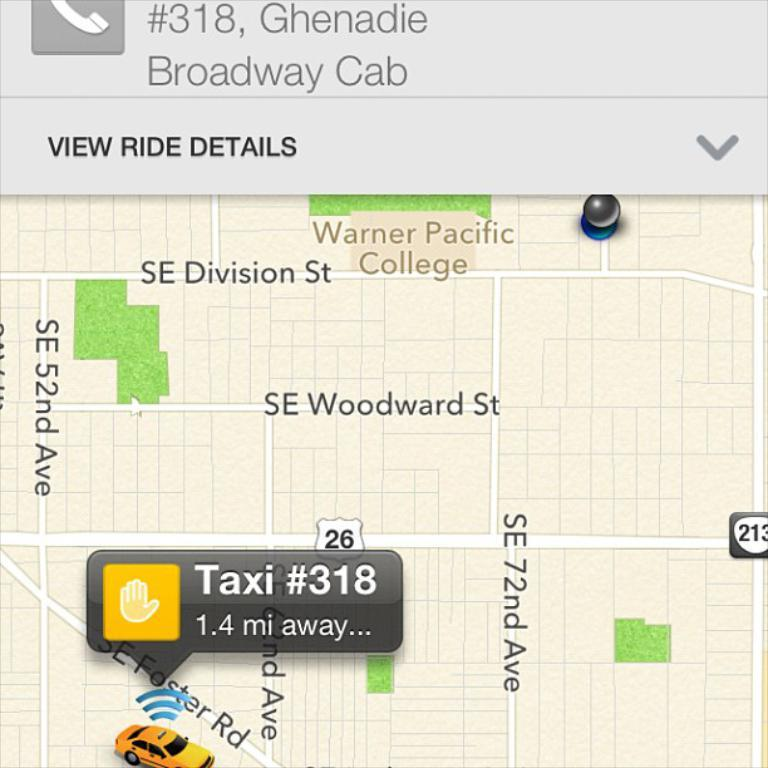<image>
Write a terse but informative summary of the picture. A taxi is 1.4 miles away on SE Faster Road. 